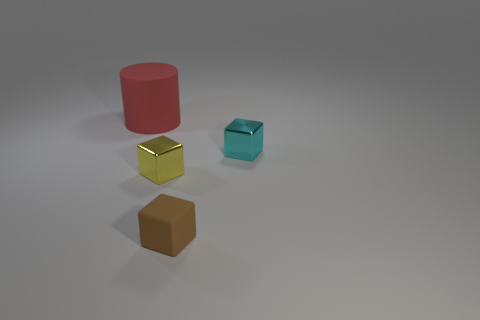Add 1 blue rubber things. How many objects exist? 5 Subtract all cubes. How many objects are left? 1 Add 3 small brown matte objects. How many small brown matte objects exist? 4 Subtract 0 brown cylinders. How many objects are left? 4 Subtract all small cyan blocks. Subtract all cyan metallic objects. How many objects are left? 2 Add 3 red things. How many red things are left? 4 